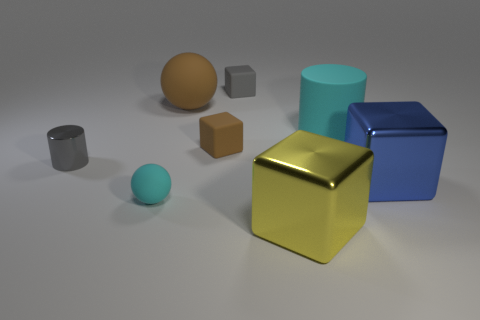How many objects are small red spheres or cyan matte cylinders?
Provide a succinct answer. 1. The other shiny thing that is the same size as the blue metallic thing is what color?
Your response must be concise. Yellow. Is the shape of the tiny cyan object the same as the brown object that is to the left of the small brown matte thing?
Offer a very short reply. Yes. How many things are tiny matte objects behind the small metal thing or blue things to the right of the shiny cylinder?
Provide a succinct answer. 3. What is the shape of the small thing that is the same color as the metal cylinder?
Give a very brief answer. Cube. What shape is the cyan object in front of the large blue block?
Your answer should be very brief. Sphere. There is a tiny gray thing that is right of the gray metallic thing; does it have the same shape as the blue object?
Keep it short and to the point. Yes. What number of things are shiny objects that are left of the tiny rubber sphere or matte balls?
Provide a succinct answer. 3. The other object that is the same shape as the large brown object is what color?
Give a very brief answer. Cyan. Is there any other thing that is the same color as the small cylinder?
Give a very brief answer. Yes. 